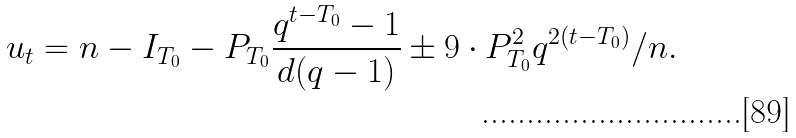Convert formula to latex. <formula><loc_0><loc_0><loc_500><loc_500>u _ { t } = n - I _ { T _ { 0 } } - P _ { T _ { 0 } } \frac { q ^ { t - T _ { 0 } } - 1 } { d ( q - 1 ) } \pm 9 \cdot P _ { T _ { 0 } } ^ { 2 } q ^ { 2 ( t - T _ { 0 } ) } / n .</formula> 